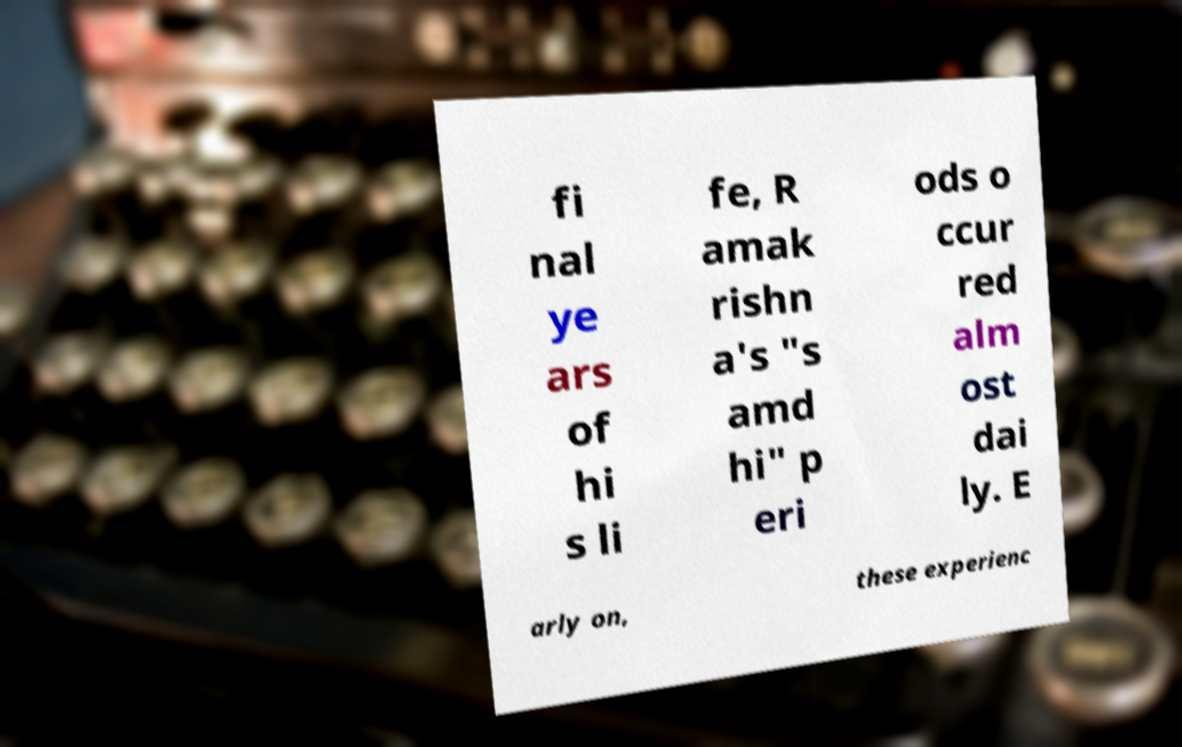Can you accurately transcribe the text from the provided image for me? fi nal ye ars of hi s li fe, R amak rishn a's "s amd hi" p eri ods o ccur red alm ost dai ly. E arly on, these experienc 